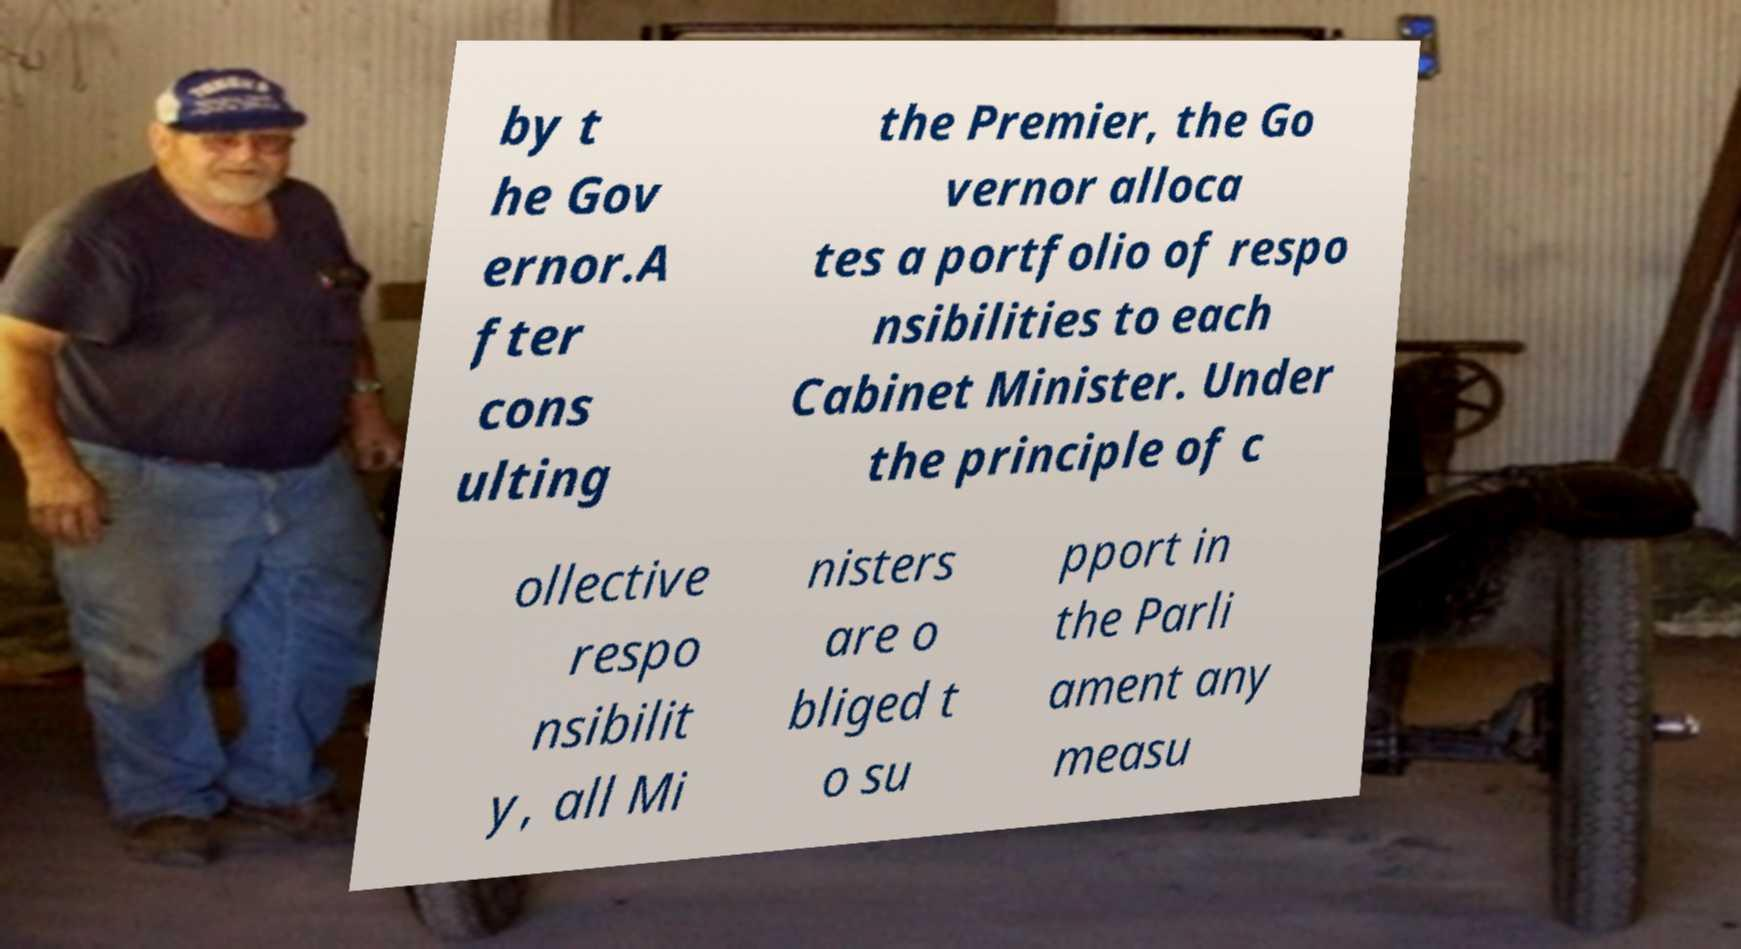Please read and relay the text visible in this image. What does it say? by t he Gov ernor.A fter cons ulting the Premier, the Go vernor alloca tes a portfolio of respo nsibilities to each Cabinet Minister. Under the principle of c ollective respo nsibilit y, all Mi nisters are o bliged t o su pport in the Parli ament any measu 